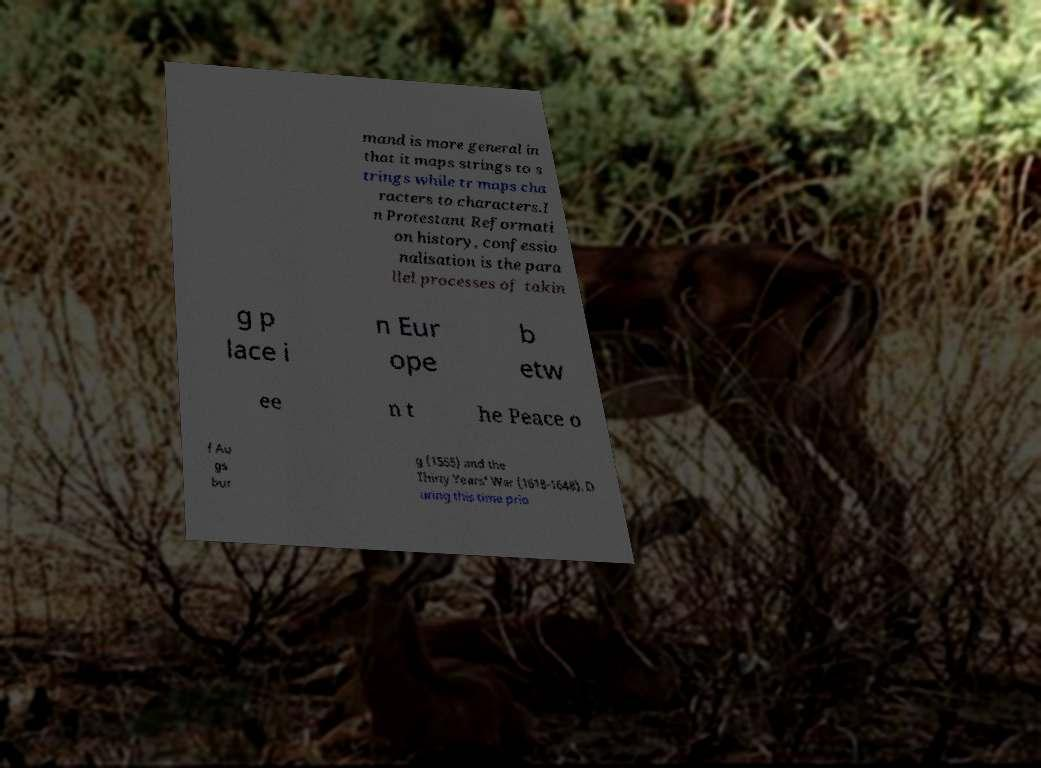Can you read and provide the text displayed in the image?This photo seems to have some interesting text. Can you extract and type it out for me? mand is more general in that it maps strings to s trings while tr maps cha racters to characters.I n Protestant Reformati on history, confessio nalisation is the para llel processes of takin g p lace i n Eur ope b etw ee n t he Peace o f Au gs bur g (1555) and the Thirty Years' War (1618-1648). D uring this time prio 